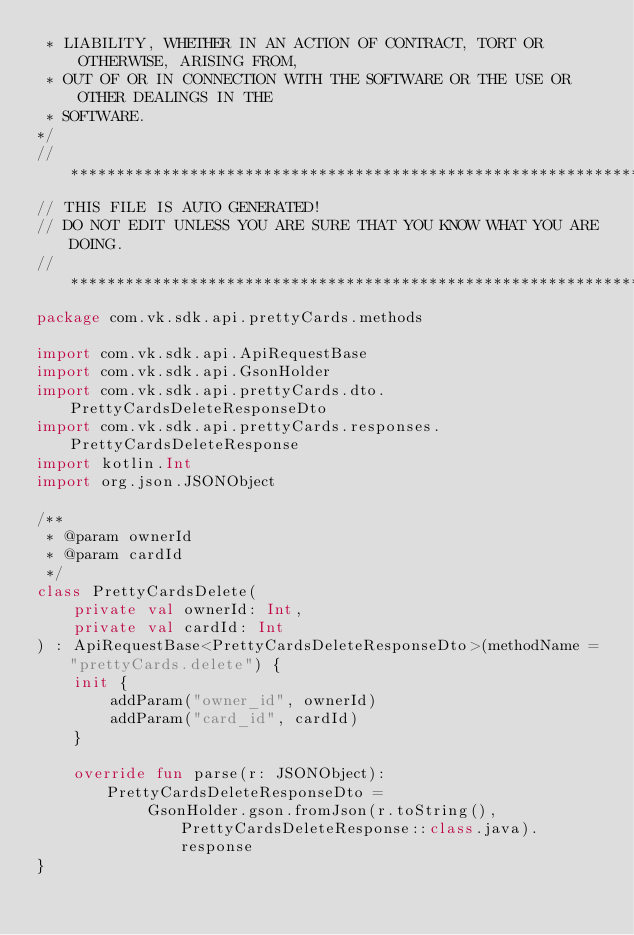Convert code to text. <code><loc_0><loc_0><loc_500><loc_500><_Kotlin_> * LIABILITY, WHETHER IN AN ACTION OF CONTRACT, TORT OR OTHERWISE, ARISING FROM,
 * OUT OF OR IN CONNECTION WITH THE SOFTWARE OR THE USE OR OTHER DEALINGS IN THE
 * SOFTWARE.
*/
// *********************************************************************
// THIS FILE IS AUTO GENERATED!
// DO NOT EDIT UNLESS YOU ARE SURE THAT YOU KNOW WHAT YOU ARE DOING.
// *********************************************************************
package com.vk.sdk.api.prettyCards.methods

import com.vk.sdk.api.ApiRequestBase
import com.vk.sdk.api.GsonHolder
import com.vk.sdk.api.prettyCards.dto.PrettyCardsDeleteResponseDto
import com.vk.sdk.api.prettyCards.responses.PrettyCardsDeleteResponse
import kotlin.Int
import org.json.JSONObject

/**
 * @param ownerId  
 * @param cardId  
 */
class PrettyCardsDelete(
    private val ownerId: Int,
    private val cardId: Int
) : ApiRequestBase<PrettyCardsDeleteResponseDto>(methodName = "prettyCards.delete") {
    init {
        addParam("owner_id", ownerId)
        addParam("card_id", cardId)
    }

    override fun parse(r: JSONObject): PrettyCardsDeleteResponseDto =
            GsonHolder.gson.fromJson(r.toString(), PrettyCardsDeleteResponse::class.java).response
}
</code> 